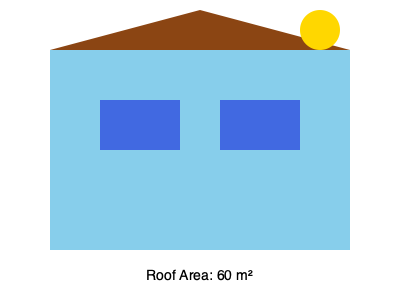You're considering installing solar panels on your family home's roof to reduce energy costs and create a more sustainable living environment. The roof has an area of 60 m² and receives an average of 5 hours of direct sunlight per day. If the solar panels cost $200 per m² to install and can generate 150 watts per m² during peak sunlight, calculate the annual energy savings in dollars if electricity costs $0.12 per kWh. Assume the system operates at 80% efficiency. How many years will it take for the installation to pay for itself? Let's break this down step-by-step:

1. Calculate the total installation cost:
   $\text{Cost} = 60 \text{ m}^2 \times \$200/\text{m}^2 = \$12,000$

2. Calculate the daily energy generation:
   $\text{Daily Energy} = 60 \text{ m}^2 \times 150 \text{ W}/\text{m}^2 \times 5 \text{ hours} \times 0.80 \text{ efficiency} = 36,000 \text{ Wh} = 36 \text{ kWh}$

3. Calculate the annual energy generation:
   $\text{Annual Energy} = 36 \text{ kWh} \times 365 \text{ days} = 13,140 \text{ kWh}$

4. Calculate the annual savings:
   $\text{Annual Savings} = 13,140 \text{ kWh} \times \$0.12/\text{kWh} = \$1,576.80$

5. Calculate the payback period:
   $\text{Payback Period} = \frac{\text{Installation Cost}}{\text{Annual Savings}} = \frac{\$12,000}{\$1,576.80} \approx 7.61 \text{ years}$

Therefore, it will take approximately 7.61 years for the solar panel installation to pay for itself.
Answer: 7.61 years 